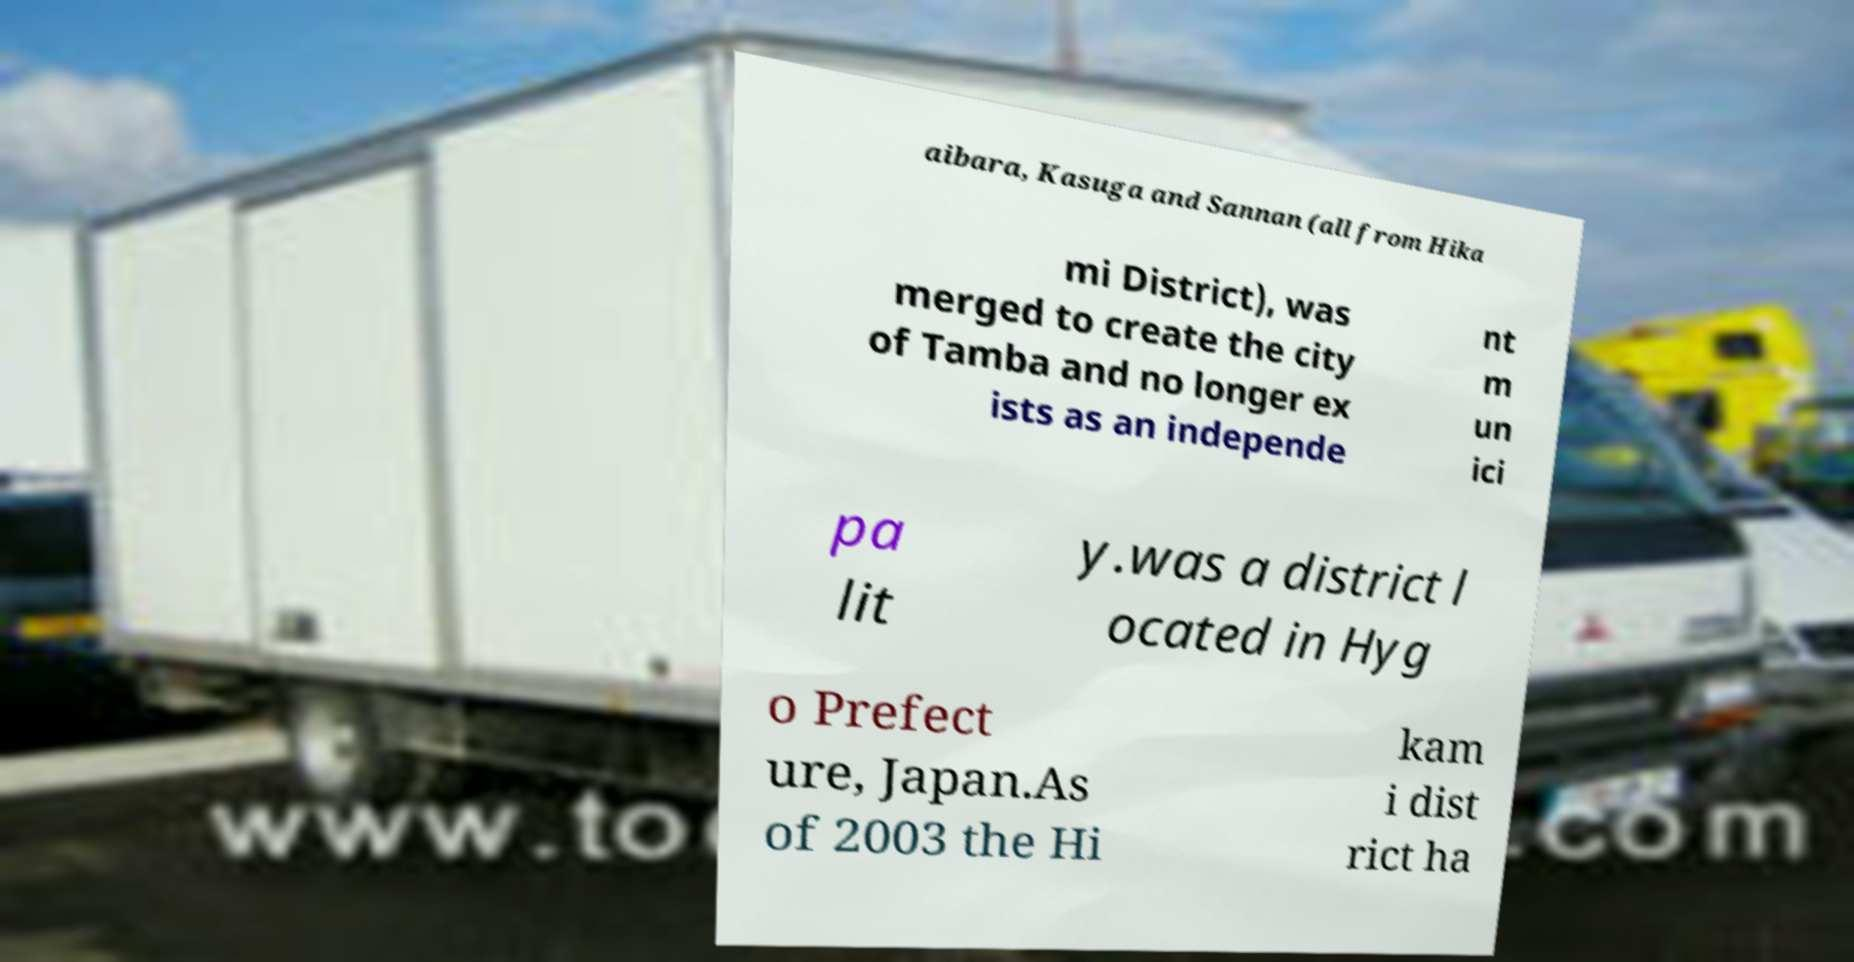Could you extract and type out the text from this image? aibara, Kasuga and Sannan (all from Hika mi District), was merged to create the city of Tamba and no longer ex ists as an independe nt m un ici pa lit y.was a district l ocated in Hyg o Prefect ure, Japan.As of 2003 the Hi kam i dist rict ha 